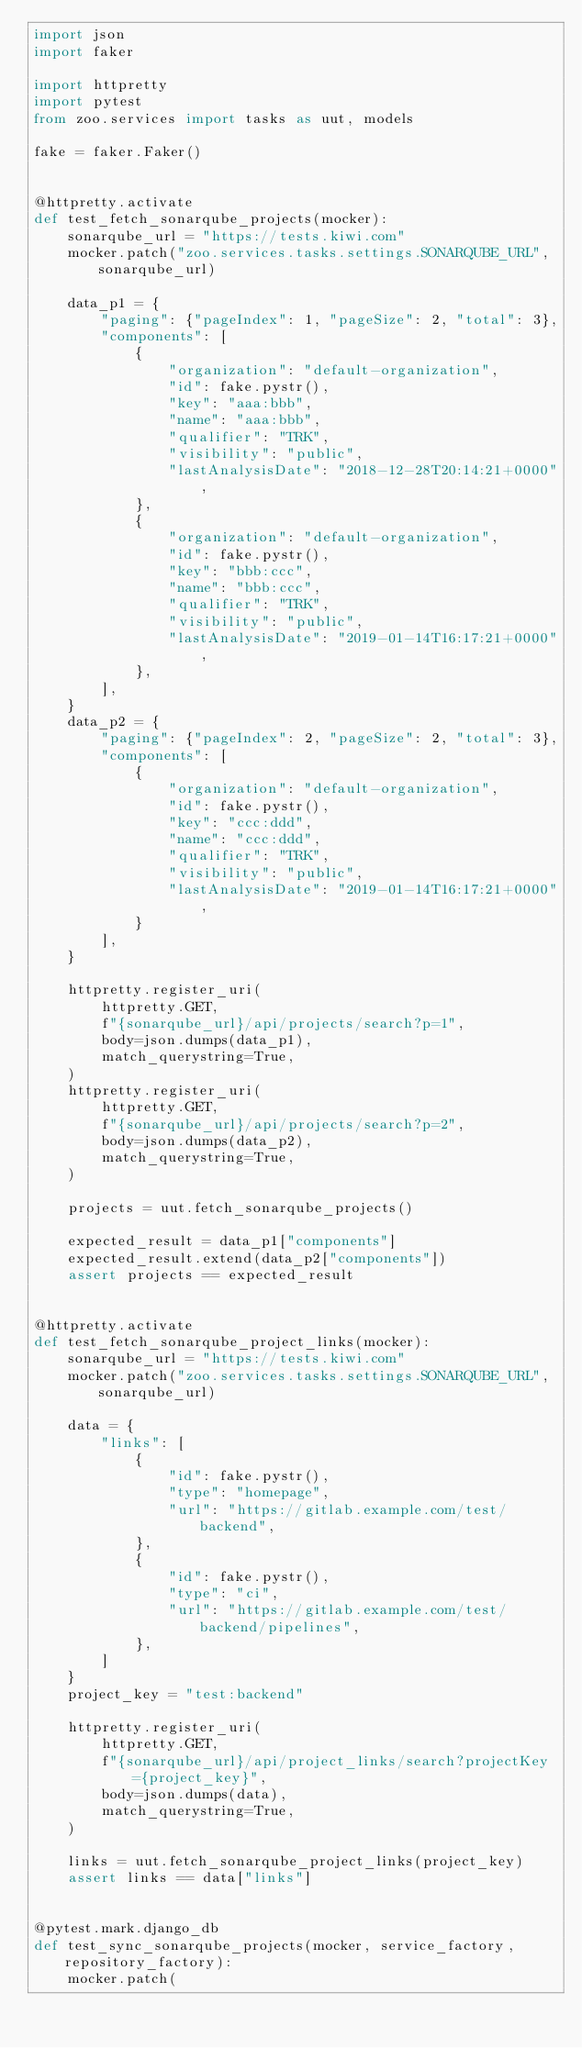Convert code to text. <code><loc_0><loc_0><loc_500><loc_500><_Python_>import json
import faker

import httpretty
import pytest
from zoo.services import tasks as uut, models

fake = faker.Faker()


@httpretty.activate
def test_fetch_sonarqube_projects(mocker):
    sonarqube_url = "https://tests.kiwi.com"
    mocker.patch("zoo.services.tasks.settings.SONARQUBE_URL", sonarqube_url)

    data_p1 = {
        "paging": {"pageIndex": 1, "pageSize": 2, "total": 3},
        "components": [
            {
                "organization": "default-organization",
                "id": fake.pystr(),
                "key": "aaa:bbb",
                "name": "aaa:bbb",
                "qualifier": "TRK",
                "visibility": "public",
                "lastAnalysisDate": "2018-12-28T20:14:21+0000",
            },
            {
                "organization": "default-organization",
                "id": fake.pystr(),
                "key": "bbb:ccc",
                "name": "bbb:ccc",
                "qualifier": "TRK",
                "visibility": "public",
                "lastAnalysisDate": "2019-01-14T16:17:21+0000",
            },
        ],
    }
    data_p2 = {
        "paging": {"pageIndex": 2, "pageSize": 2, "total": 3},
        "components": [
            {
                "organization": "default-organization",
                "id": fake.pystr(),
                "key": "ccc:ddd",
                "name": "ccc:ddd",
                "qualifier": "TRK",
                "visibility": "public",
                "lastAnalysisDate": "2019-01-14T16:17:21+0000",
            }
        ],
    }

    httpretty.register_uri(
        httpretty.GET,
        f"{sonarqube_url}/api/projects/search?p=1",
        body=json.dumps(data_p1),
        match_querystring=True,
    )
    httpretty.register_uri(
        httpretty.GET,
        f"{sonarqube_url}/api/projects/search?p=2",
        body=json.dumps(data_p2),
        match_querystring=True,
    )

    projects = uut.fetch_sonarqube_projects()

    expected_result = data_p1["components"]
    expected_result.extend(data_p2["components"])
    assert projects == expected_result


@httpretty.activate
def test_fetch_sonarqube_project_links(mocker):
    sonarqube_url = "https://tests.kiwi.com"
    mocker.patch("zoo.services.tasks.settings.SONARQUBE_URL", sonarqube_url)

    data = {
        "links": [
            {
                "id": fake.pystr(),
                "type": "homepage",
                "url": "https://gitlab.example.com/test/backend",
            },
            {
                "id": fake.pystr(),
                "type": "ci",
                "url": "https://gitlab.example.com/test/backend/pipelines",
            },
        ]
    }
    project_key = "test:backend"

    httpretty.register_uri(
        httpretty.GET,
        f"{sonarqube_url}/api/project_links/search?projectKey={project_key}",
        body=json.dumps(data),
        match_querystring=True,
    )

    links = uut.fetch_sonarqube_project_links(project_key)
    assert links == data["links"]


@pytest.mark.django_db
def test_sync_sonarqube_projects(mocker, service_factory, repository_factory):
    mocker.patch(</code> 